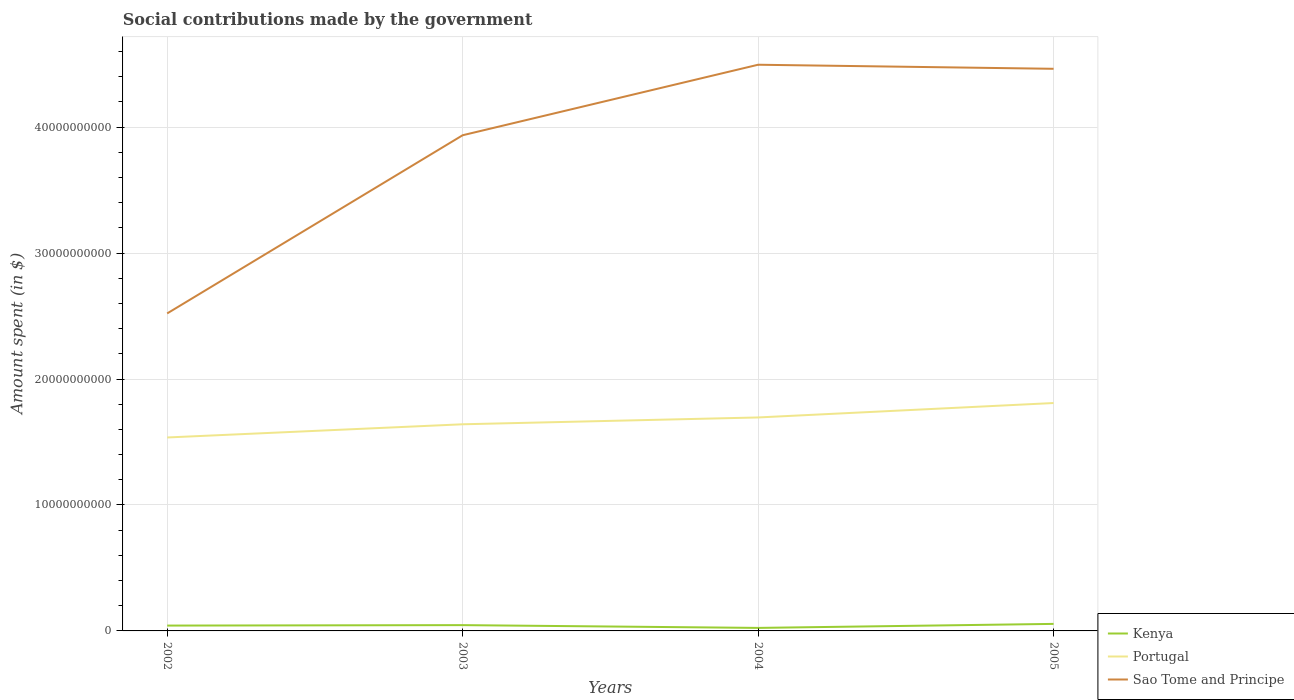How many different coloured lines are there?
Make the answer very short. 3. Does the line corresponding to Sao Tome and Principe intersect with the line corresponding to Portugal?
Ensure brevity in your answer.  No. Across all years, what is the maximum amount spent on social contributions in Sao Tome and Principe?
Provide a short and direct response. 2.52e+1. What is the total amount spent on social contributions in Sao Tome and Principe in the graph?
Offer a terse response. -5.60e+09. What is the difference between the highest and the second highest amount spent on social contributions in Sao Tome and Principe?
Offer a terse response. 1.97e+1. What is the difference between the highest and the lowest amount spent on social contributions in Sao Tome and Principe?
Your response must be concise. 3. Is the amount spent on social contributions in Portugal strictly greater than the amount spent on social contributions in Sao Tome and Principe over the years?
Offer a very short reply. Yes. How many lines are there?
Offer a terse response. 3. Are the values on the major ticks of Y-axis written in scientific E-notation?
Give a very brief answer. No. How are the legend labels stacked?
Keep it short and to the point. Vertical. What is the title of the graph?
Provide a short and direct response. Social contributions made by the government. Does "Nigeria" appear as one of the legend labels in the graph?
Provide a succinct answer. No. What is the label or title of the Y-axis?
Make the answer very short. Amount spent (in $). What is the Amount spent (in $) in Kenya in 2002?
Keep it short and to the point. 4.24e+08. What is the Amount spent (in $) in Portugal in 2002?
Provide a short and direct response. 1.54e+1. What is the Amount spent (in $) in Sao Tome and Principe in 2002?
Offer a terse response. 2.52e+1. What is the Amount spent (in $) in Kenya in 2003?
Ensure brevity in your answer.  4.60e+08. What is the Amount spent (in $) of Portugal in 2003?
Give a very brief answer. 1.64e+1. What is the Amount spent (in $) in Sao Tome and Principe in 2003?
Ensure brevity in your answer.  3.94e+1. What is the Amount spent (in $) of Kenya in 2004?
Offer a very short reply. 2.39e+08. What is the Amount spent (in $) in Portugal in 2004?
Provide a succinct answer. 1.69e+1. What is the Amount spent (in $) in Sao Tome and Principe in 2004?
Your answer should be compact. 4.50e+1. What is the Amount spent (in $) of Kenya in 2005?
Your answer should be very brief. 5.58e+08. What is the Amount spent (in $) in Portugal in 2005?
Provide a succinct answer. 1.81e+1. What is the Amount spent (in $) in Sao Tome and Principe in 2005?
Provide a succinct answer. 4.46e+1. Across all years, what is the maximum Amount spent (in $) of Kenya?
Give a very brief answer. 5.58e+08. Across all years, what is the maximum Amount spent (in $) in Portugal?
Offer a terse response. 1.81e+1. Across all years, what is the maximum Amount spent (in $) of Sao Tome and Principe?
Keep it short and to the point. 4.50e+1. Across all years, what is the minimum Amount spent (in $) of Kenya?
Your answer should be very brief. 2.39e+08. Across all years, what is the minimum Amount spent (in $) of Portugal?
Provide a succinct answer. 1.54e+1. Across all years, what is the minimum Amount spent (in $) of Sao Tome and Principe?
Give a very brief answer. 2.52e+1. What is the total Amount spent (in $) in Kenya in the graph?
Your response must be concise. 1.68e+09. What is the total Amount spent (in $) in Portugal in the graph?
Offer a very short reply. 6.68e+1. What is the total Amount spent (in $) of Sao Tome and Principe in the graph?
Provide a short and direct response. 1.54e+11. What is the difference between the Amount spent (in $) of Kenya in 2002 and that in 2003?
Keep it short and to the point. -3.62e+07. What is the difference between the Amount spent (in $) in Portugal in 2002 and that in 2003?
Give a very brief answer. -1.05e+09. What is the difference between the Amount spent (in $) in Sao Tome and Principe in 2002 and that in 2003?
Offer a terse response. -1.41e+1. What is the difference between the Amount spent (in $) in Kenya in 2002 and that in 2004?
Keep it short and to the point. 1.85e+08. What is the difference between the Amount spent (in $) in Portugal in 2002 and that in 2004?
Offer a very short reply. -1.59e+09. What is the difference between the Amount spent (in $) in Sao Tome and Principe in 2002 and that in 2004?
Your response must be concise. -1.97e+1. What is the difference between the Amount spent (in $) of Kenya in 2002 and that in 2005?
Your answer should be compact. -1.34e+08. What is the difference between the Amount spent (in $) of Portugal in 2002 and that in 2005?
Your response must be concise. -2.74e+09. What is the difference between the Amount spent (in $) in Sao Tome and Principe in 2002 and that in 2005?
Make the answer very short. -1.94e+1. What is the difference between the Amount spent (in $) in Kenya in 2003 and that in 2004?
Make the answer very short. 2.21e+08. What is the difference between the Amount spent (in $) in Portugal in 2003 and that in 2004?
Offer a very short reply. -5.42e+08. What is the difference between the Amount spent (in $) of Sao Tome and Principe in 2003 and that in 2004?
Your answer should be compact. -5.60e+09. What is the difference between the Amount spent (in $) of Kenya in 2003 and that in 2005?
Keep it short and to the point. -9.81e+07. What is the difference between the Amount spent (in $) in Portugal in 2003 and that in 2005?
Your answer should be compact. -1.69e+09. What is the difference between the Amount spent (in $) of Sao Tome and Principe in 2003 and that in 2005?
Provide a succinct answer. -5.28e+09. What is the difference between the Amount spent (in $) in Kenya in 2004 and that in 2005?
Keep it short and to the point. -3.19e+08. What is the difference between the Amount spent (in $) in Portugal in 2004 and that in 2005?
Your answer should be compact. -1.15e+09. What is the difference between the Amount spent (in $) in Sao Tome and Principe in 2004 and that in 2005?
Offer a very short reply. 3.23e+08. What is the difference between the Amount spent (in $) in Kenya in 2002 and the Amount spent (in $) in Portugal in 2003?
Your answer should be compact. -1.60e+1. What is the difference between the Amount spent (in $) in Kenya in 2002 and the Amount spent (in $) in Sao Tome and Principe in 2003?
Give a very brief answer. -3.89e+1. What is the difference between the Amount spent (in $) in Portugal in 2002 and the Amount spent (in $) in Sao Tome and Principe in 2003?
Provide a short and direct response. -2.40e+1. What is the difference between the Amount spent (in $) of Kenya in 2002 and the Amount spent (in $) of Portugal in 2004?
Give a very brief answer. -1.65e+1. What is the difference between the Amount spent (in $) of Kenya in 2002 and the Amount spent (in $) of Sao Tome and Principe in 2004?
Make the answer very short. -4.45e+1. What is the difference between the Amount spent (in $) of Portugal in 2002 and the Amount spent (in $) of Sao Tome and Principe in 2004?
Your answer should be very brief. -2.96e+1. What is the difference between the Amount spent (in $) of Kenya in 2002 and the Amount spent (in $) of Portugal in 2005?
Your answer should be compact. -1.77e+1. What is the difference between the Amount spent (in $) in Kenya in 2002 and the Amount spent (in $) in Sao Tome and Principe in 2005?
Your answer should be very brief. -4.42e+1. What is the difference between the Amount spent (in $) in Portugal in 2002 and the Amount spent (in $) in Sao Tome and Principe in 2005?
Provide a short and direct response. -2.93e+1. What is the difference between the Amount spent (in $) of Kenya in 2003 and the Amount spent (in $) of Portugal in 2004?
Provide a short and direct response. -1.65e+1. What is the difference between the Amount spent (in $) of Kenya in 2003 and the Amount spent (in $) of Sao Tome and Principe in 2004?
Keep it short and to the point. -4.45e+1. What is the difference between the Amount spent (in $) in Portugal in 2003 and the Amount spent (in $) in Sao Tome and Principe in 2004?
Your answer should be compact. -2.85e+1. What is the difference between the Amount spent (in $) of Kenya in 2003 and the Amount spent (in $) of Portugal in 2005?
Provide a short and direct response. -1.76e+1. What is the difference between the Amount spent (in $) of Kenya in 2003 and the Amount spent (in $) of Sao Tome and Principe in 2005?
Provide a short and direct response. -4.42e+1. What is the difference between the Amount spent (in $) in Portugal in 2003 and the Amount spent (in $) in Sao Tome and Principe in 2005?
Your response must be concise. -2.82e+1. What is the difference between the Amount spent (in $) of Kenya in 2004 and the Amount spent (in $) of Portugal in 2005?
Provide a short and direct response. -1.79e+1. What is the difference between the Amount spent (in $) of Kenya in 2004 and the Amount spent (in $) of Sao Tome and Principe in 2005?
Keep it short and to the point. -4.44e+1. What is the difference between the Amount spent (in $) in Portugal in 2004 and the Amount spent (in $) in Sao Tome and Principe in 2005?
Ensure brevity in your answer.  -2.77e+1. What is the average Amount spent (in $) of Kenya per year?
Your answer should be very brief. 4.20e+08. What is the average Amount spent (in $) in Portugal per year?
Give a very brief answer. 1.67e+1. What is the average Amount spent (in $) of Sao Tome and Principe per year?
Your answer should be very brief. 3.85e+1. In the year 2002, what is the difference between the Amount spent (in $) in Kenya and Amount spent (in $) in Portugal?
Your response must be concise. -1.49e+1. In the year 2002, what is the difference between the Amount spent (in $) of Kenya and Amount spent (in $) of Sao Tome and Principe?
Your response must be concise. -2.48e+1. In the year 2002, what is the difference between the Amount spent (in $) in Portugal and Amount spent (in $) in Sao Tome and Principe?
Keep it short and to the point. -9.85e+09. In the year 2003, what is the difference between the Amount spent (in $) in Kenya and Amount spent (in $) in Portugal?
Offer a terse response. -1.59e+1. In the year 2003, what is the difference between the Amount spent (in $) in Kenya and Amount spent (in $) in Sao Tome and Principe?
Make the answer very short. -3.89e+1. In the year 2003, what is the difference between the Amount spent (in $) in Portugal and Amount spent (in $) in Sao Tome and Principe?
Your response must be concise. -2.29e+1. In the year 2004, what is the difference between the Amount spent (in $) of Kenya and Amount spent (in $) of Portugal?
Offer a very short reply. -1.67e+1. In the year 2004, what is the difference between the Amount spent (in $) of Kenya and Amount spent (in $) of Sao Tome and Principe?
Your answer should be very brief. -4.47e+1. In the year 2004, what is the difference between the Amount spent (in $) in Portugal and Amount spent (in $) in Sao Tome and Principe?
Your answer should be compact. -2.80e+1. In the year 2005, what is the difference between the Amount spent (in $) in Kenya and Amount spent (in $) in Portugal?
Your response must be concise. -1.75e+1. In the year 2005, what is the difference between the Amount spent (in $) in Kenya and Amount spent (in $) in Sao Tome and Principe?
Give a very brief answer. -4.41e+1. In the year 2005, what is the difference between the Amount spent (in $) in Portugal and Amount spent (in $) in Sao Tome and Principe?
Ensure brevity in your answer.  -2.65e+1. What is the ratio of the Amount spent (in $) in Kenya in 2002 to that in 2003?
Offer a terse response. 0.92. What is the ratio of the Amount spent (in $) of Portugal in 2002 to that in 2003?
Ensure brevity in your answer.  0.94. What is the ratio of the Amount spent (in $) of Sao Tome and Principe in 2002 to that in 2003?
Ensure brevity in your answer.  0.64. What is the ratio of the Amount spent (in $) of Kenya in 2002 to that in 2004?
Keep it short and to the point. 1.77. What is the ratio of the Amount spent (in $) in Portugal in 2002 to that in 2004?
Your answer should be very brief. 0.91. What is the ratio of the Amount spent (in $) of Sao Tome and Principe in 2002 to that in 2004?
Ensure brevity in your answer.  0.56. What is the ratio of the Amount spent (in $) in Kenya in 2002 to that in 2005?
Provide a succinct answer. 0.76. What is the ratio of the Amount spent (in $) of Portugal in 2002 to that in 2005?
Your answer should be compact. 0.85. What is the ratio of the Amount spent (in $) in Sao Tome and Principe in 2002 to that in 2005?
Offer a terse response. 0.56. What is the ratio of the Amount spent (in $) of Kenya in 2003 to that in 2004?
Your response must be concise. 1.92. What is the ratio of the Amount spent (in $) in Portugal in 2003 to that in 2004?
Your answer should be compact. 0.97. What is the ratio of the Amount spent (in $) of Sao Tome and Principe in 2003 to that in 2004?
Provide a short and direct response. 0.88. What is the ratio of the Amount spent (in $) in Kenya in 2003 to that in 2005?
Your response must be concise. 0.82. What is the ratio of the Amount spent (in $) in Portugal in 2003 to that in 2005?
Provide a short and direct response. 0.91. What is the ratio of the Amount spent (in $) of Sao Tome and Principe in 2003 to that in 2005?
Your answer should be compact. 0.88. What is the ratio of the Amount spent (in $) in Kenya in 2004 to that in 2005?
Keep it short and to the point. 0.43. What is the ratio of the Amount spent (in $) in Portugal in 2004 to that in 2005?
Your answer should be compact. 0.94. What is the ratio of the Amount spent (in $) in Sao Tome and Principe in 2004 to that in 2005?
Provide a short and direct response. 1.01. What is the difference between the highest and the second highest Amount spent (in $) in Kenya?
Your response must be concise. 9.81e+07. What is the difference between the highest and the second highest Amount spent (in $) of Portugal?
Your answer should be compact. 1.15e+09. What is the difference between the highest and the second highest Amount spent (in $) of Sao Tome and Principe?
Your answer should be compact. 3.23e+08. What is the difference between the highest and the lowest Amount spent (in $) in Kenya?
Provide a short and direct response. 3.19e+08. What is the difference between the highest and the lowest Amount spent (in $) of Portugal?
Make the answer very short. 2.74e+09. What is the difference between the highest and the lowest Amount spent (in $) of Sao Tome and Principe?
Your response must be concise. 1.97e+1. 